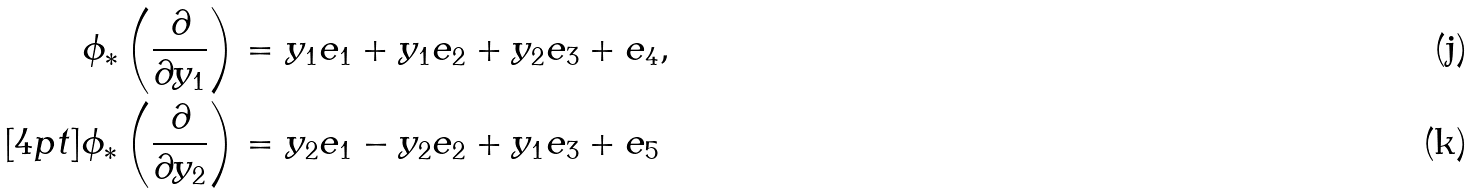<formula> <loc_0><loc_0><loc_500><loc_500>\phi _ { * } \left ( \frac { \partial } { \partial y _ { 1 } } \right ) & = y _ { 1 } e _ { 1 } + y _ { 1 } e _ { 2 } + y _ { 2 } e _ { 3 } + e _ { 4 } , \\ [ 4 p t ] \phi _ { * } \left ( \frac { \partial } { \partial y _ { 2 } } \right ) & = y _ { 2 } e _ { 1 } - y _ { 2 } e _ { 2 } + y _ { 1 } e _ { 3 } + e _ { 5 }</formula> 